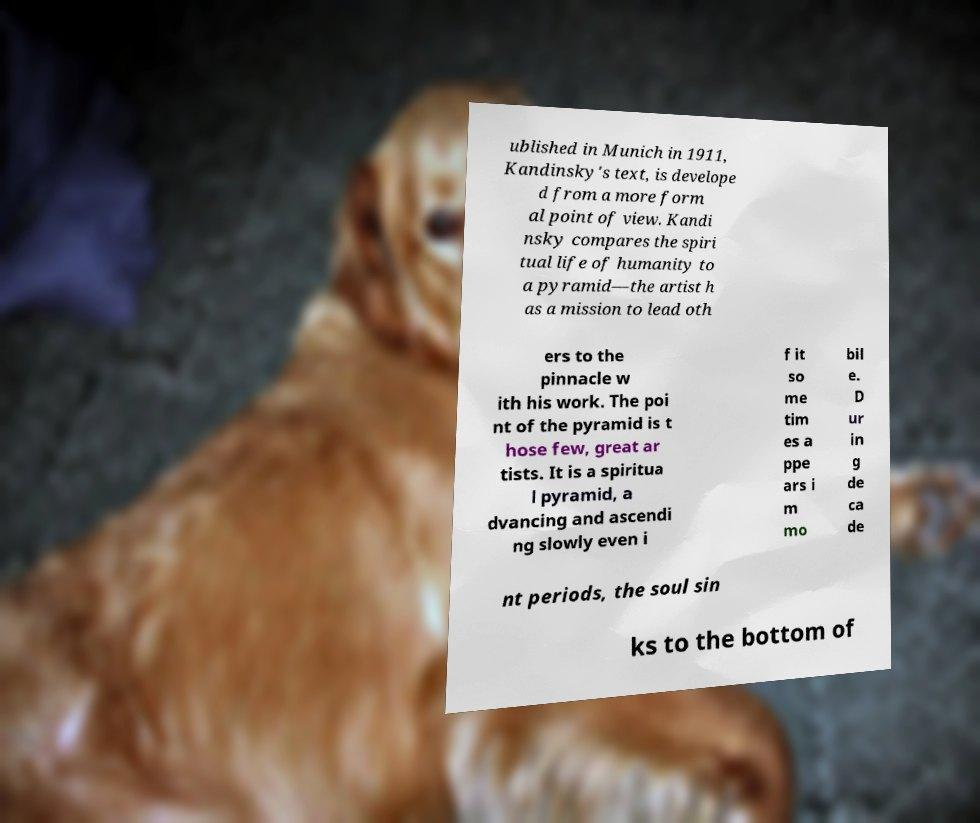Please read and relay the text visible in this image. What does it say? ublished in Munich in 1911, Kandinsky's text, is develope d from a more form al point of view. Kandi nsky compares the spiri tual life of humanity to a pyramid—the artist h as a mission to lead oth ers to the pinnacle w ith his work. The poi nt of the pyramid is t hose few, great ar tists. It is a spiritua l pyramid, a dvancing and ascendi ng slowly even i f it so me tim es a ppe ars i m mo bil e. D ur in g de ca de nt periods, the soul sin ks to the bottom of 